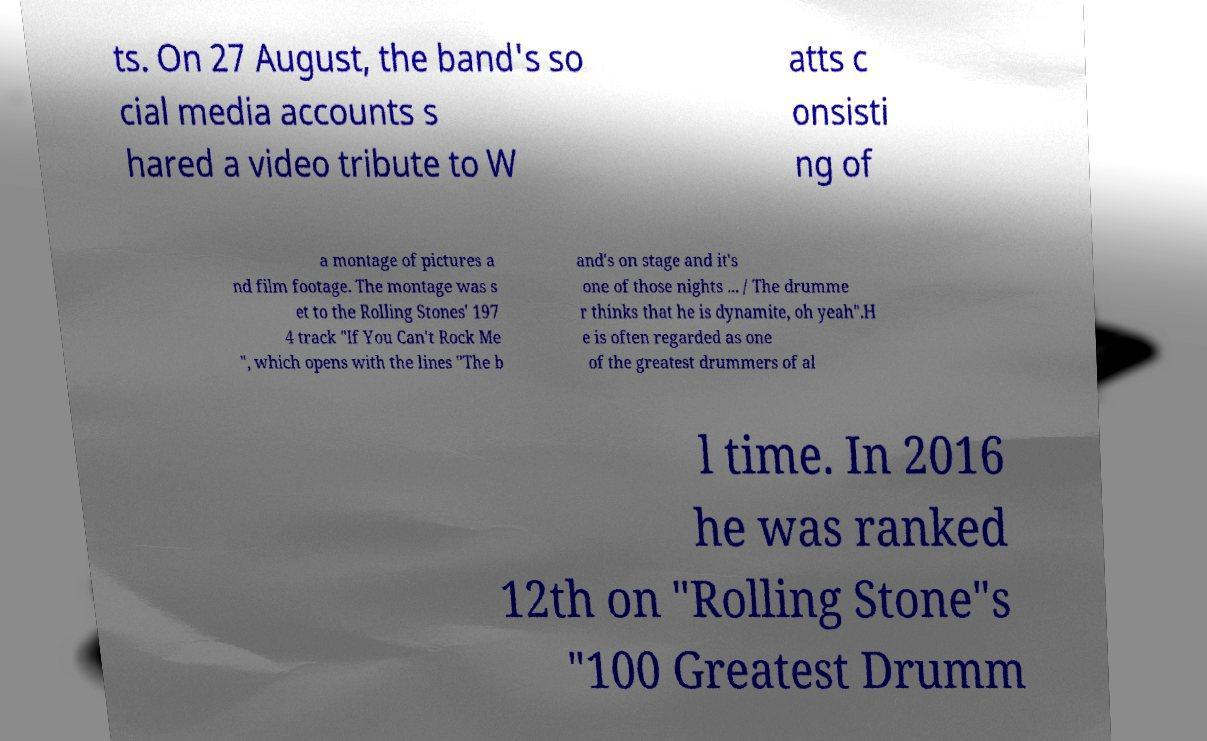Can you accurately transcribe the text from the provided image for me? ts. On 27 August, the band's so cial media accounts s hared a video tribute to W atts c onsisti ng of a montage of pictures a nd film footage. The montage was s et to the Rolling Stones' 197 4 track "If You Can't Rock Me ", which opens with the lines "The b and's on stage and it's one of those nights ... / The drumme r thinks that he is dynamite, oh yeah".H e is often regarded as one of the greatest drummers of al l time. In 2016 he was ranked 12th on "Rolling Stone"s "100 Greatest Drumm 